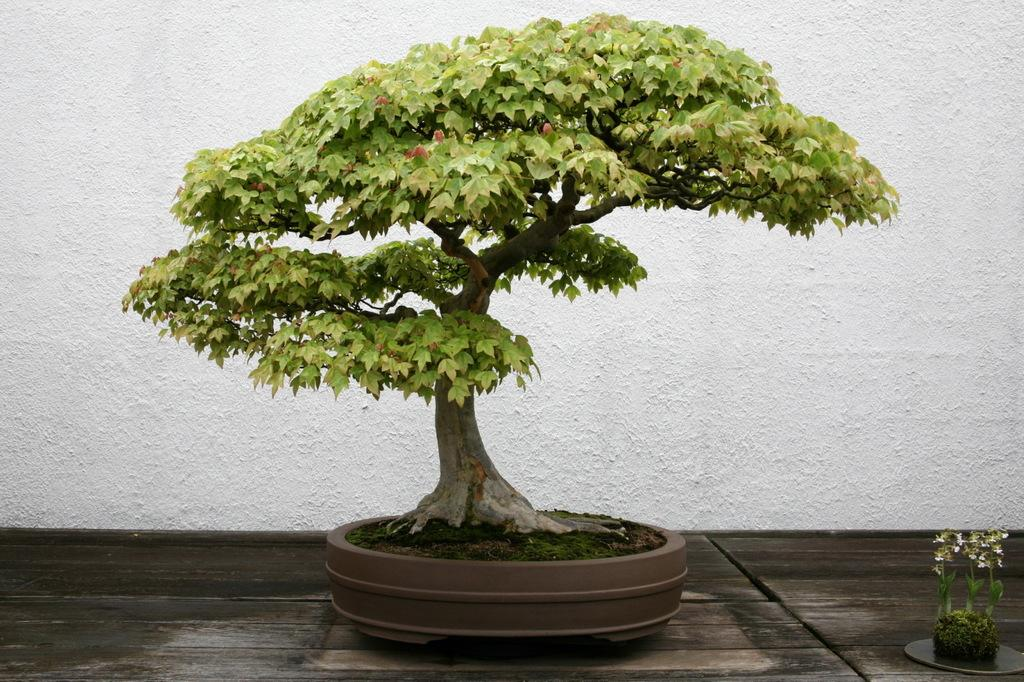How many plants are visible in the image? There are two plants in the image. What is the surface on which the plants are placed? The plants are on a wooden surface. What can be seen in the background of the image? There is a wall in the image. Where is the library located in the image? There is no library present in the image. Can you see a boot on the wooden surface with the plants? No, there is no boot visible in the image. 